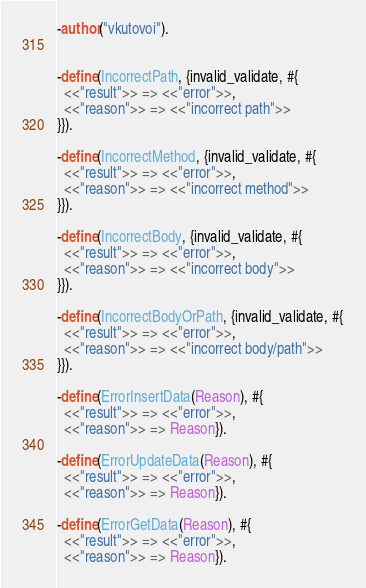Convert code to text. <code><loc_0><loc_0><loc_500><loc_500><_Erlang_>-author("vkutovoi").


-define(IncorrectPath, {invalid_validate, #{
  <<"result">> => <<"error">>,
  <<"reason">> => <<"incorrect path">>
}}).

-define(IncorrectMethod, {invalid_validate, #{
  <<"result">> => <<"error">>,
  <<"reason">> => <<"incorrect method">>
}}).

-define(IncorrectBody, {invalid_validate, #{
  <<"result">> => <<"error">>,
  <<"reason">> => <<"incorrect body">>
}}).

-define(IncorrectBodyOrPath, {invalid_validate, #{
  <<"result">> => <<"error">>,
  <<"reason">> => <<"incorrect body/path">>
}}).

-define(ErrorInsertData(Reason), #{
  <<"result">> => <<"error">>,
  <<"reason">> => Reason}).

-define(ErrorUpdateData(Reason), #{
  <<"result">> => <<"error">>,
  <<"reason">> => Reason}).

-define(ErrorGetData(Reason), #{
  <<"result">> => <<"error">>,
  <<"reason">> => Reason}).</code> 